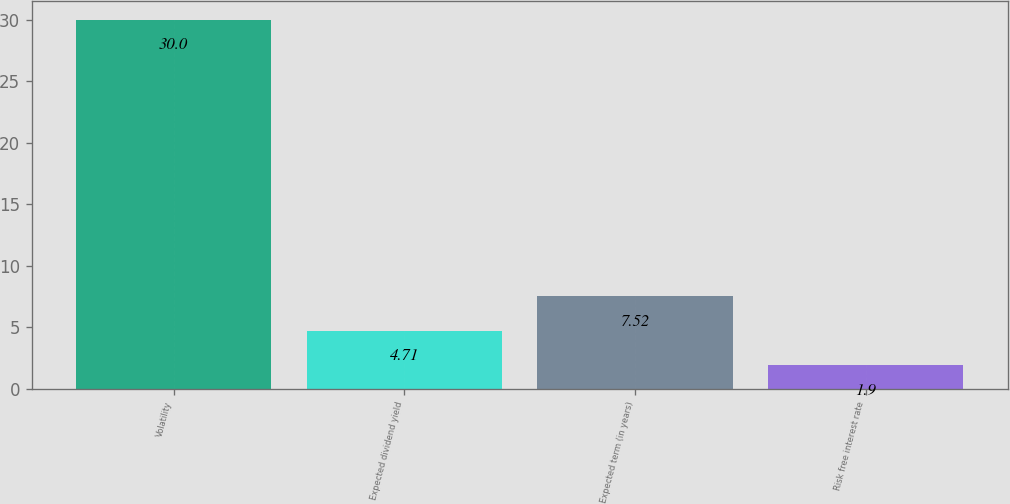Convert chart. <chart><loc_0><loc_0><loc_500><loc_500><bar_chart><fcel>Volatility<fcel>Expected dividend yield<fcel>Expected term (in years)<fcel>Risk free interest rate<nl><fcel>30<fcel>4.71<fcel>7.52<fcel>1.9<nl></chart> 